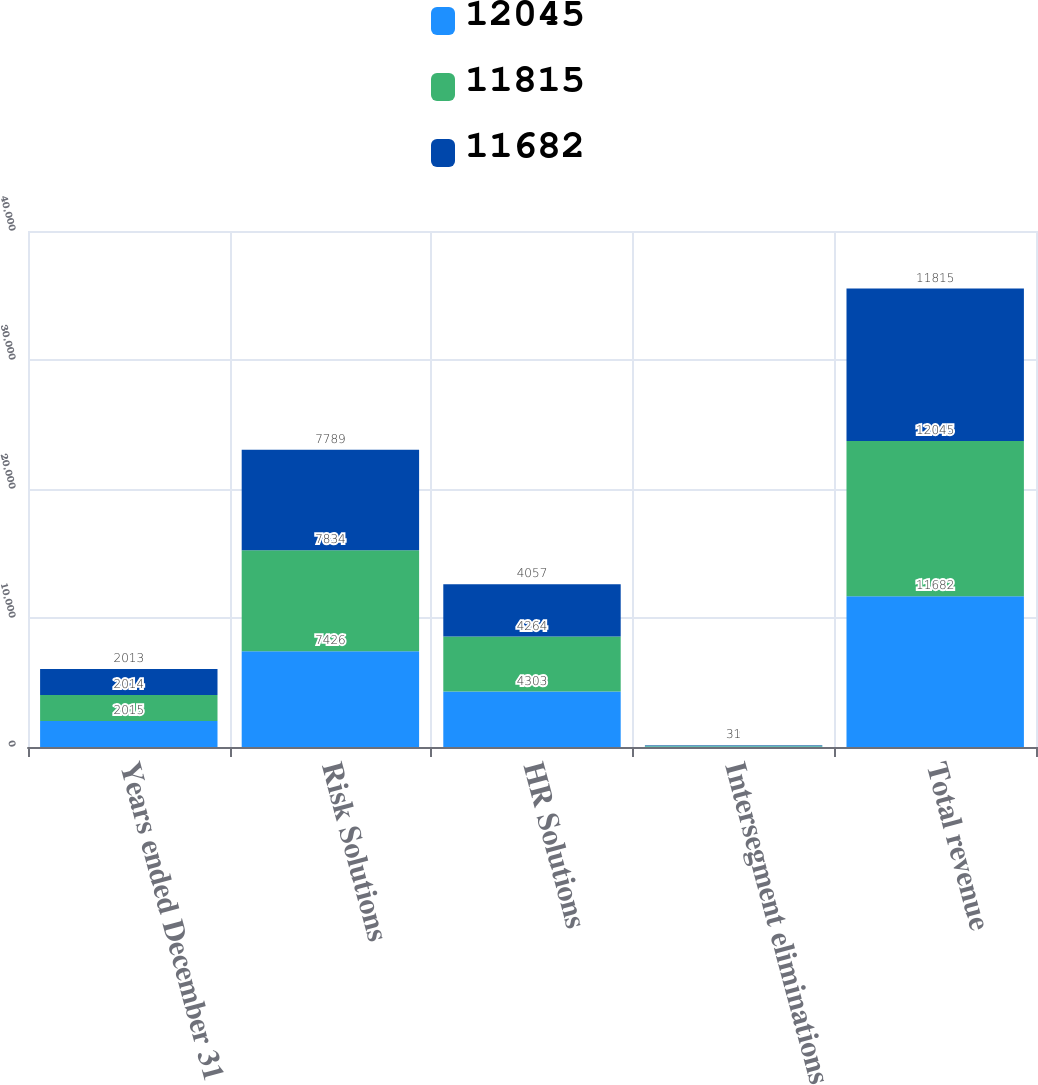<chart> <loc_0><loc_0><loc_500><loc_500><stacked_bar_chart><ecel><fcel>Years ended December 31<fcel>Risk Solutions<fcel>HR Solutions<fcel>Intersegment eliminations<fcel>Total revenue<nl><fcel>12045<fcel>2015<fcel>7426<fcel>4303<fcel>47<fcel>11682<nl><fcel>11815<fcel>2014<fcel>7834<fcel>4264<fcel>53<fcel>12045<nl><fcel>11682<fcel>2013<fcel>7789<fcel>4057<fcel>31<fcel>11815<nl></chart> 